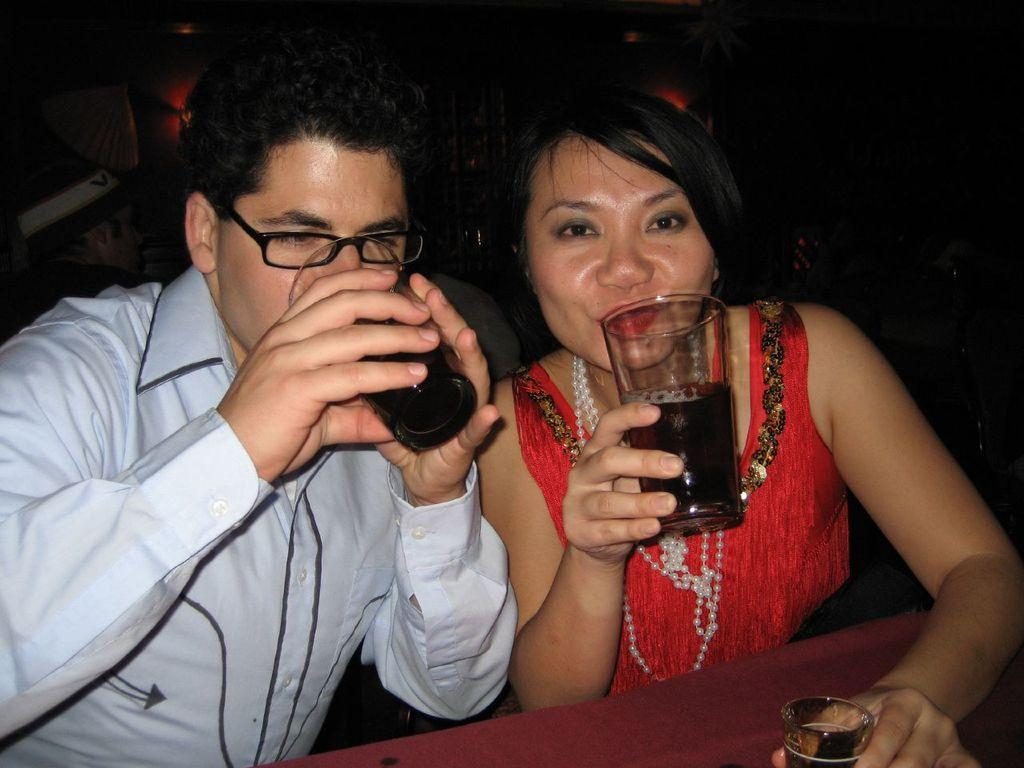How many people are in the image? There are two persons sitting in the center of the image. What are the persons holding in their hands? The persons are holding a glass in their hands. What is located at the bottom of the image? There is a table at the bottom of the image. What is present on the table? A glass is present on the table. What type of box is being used to serve the oatmeal in the image? There is no box or oatmeal present in the image. Can you describe the street where the scene in the image is taking place? The image does not provide any information about a street or an outdoor location. 